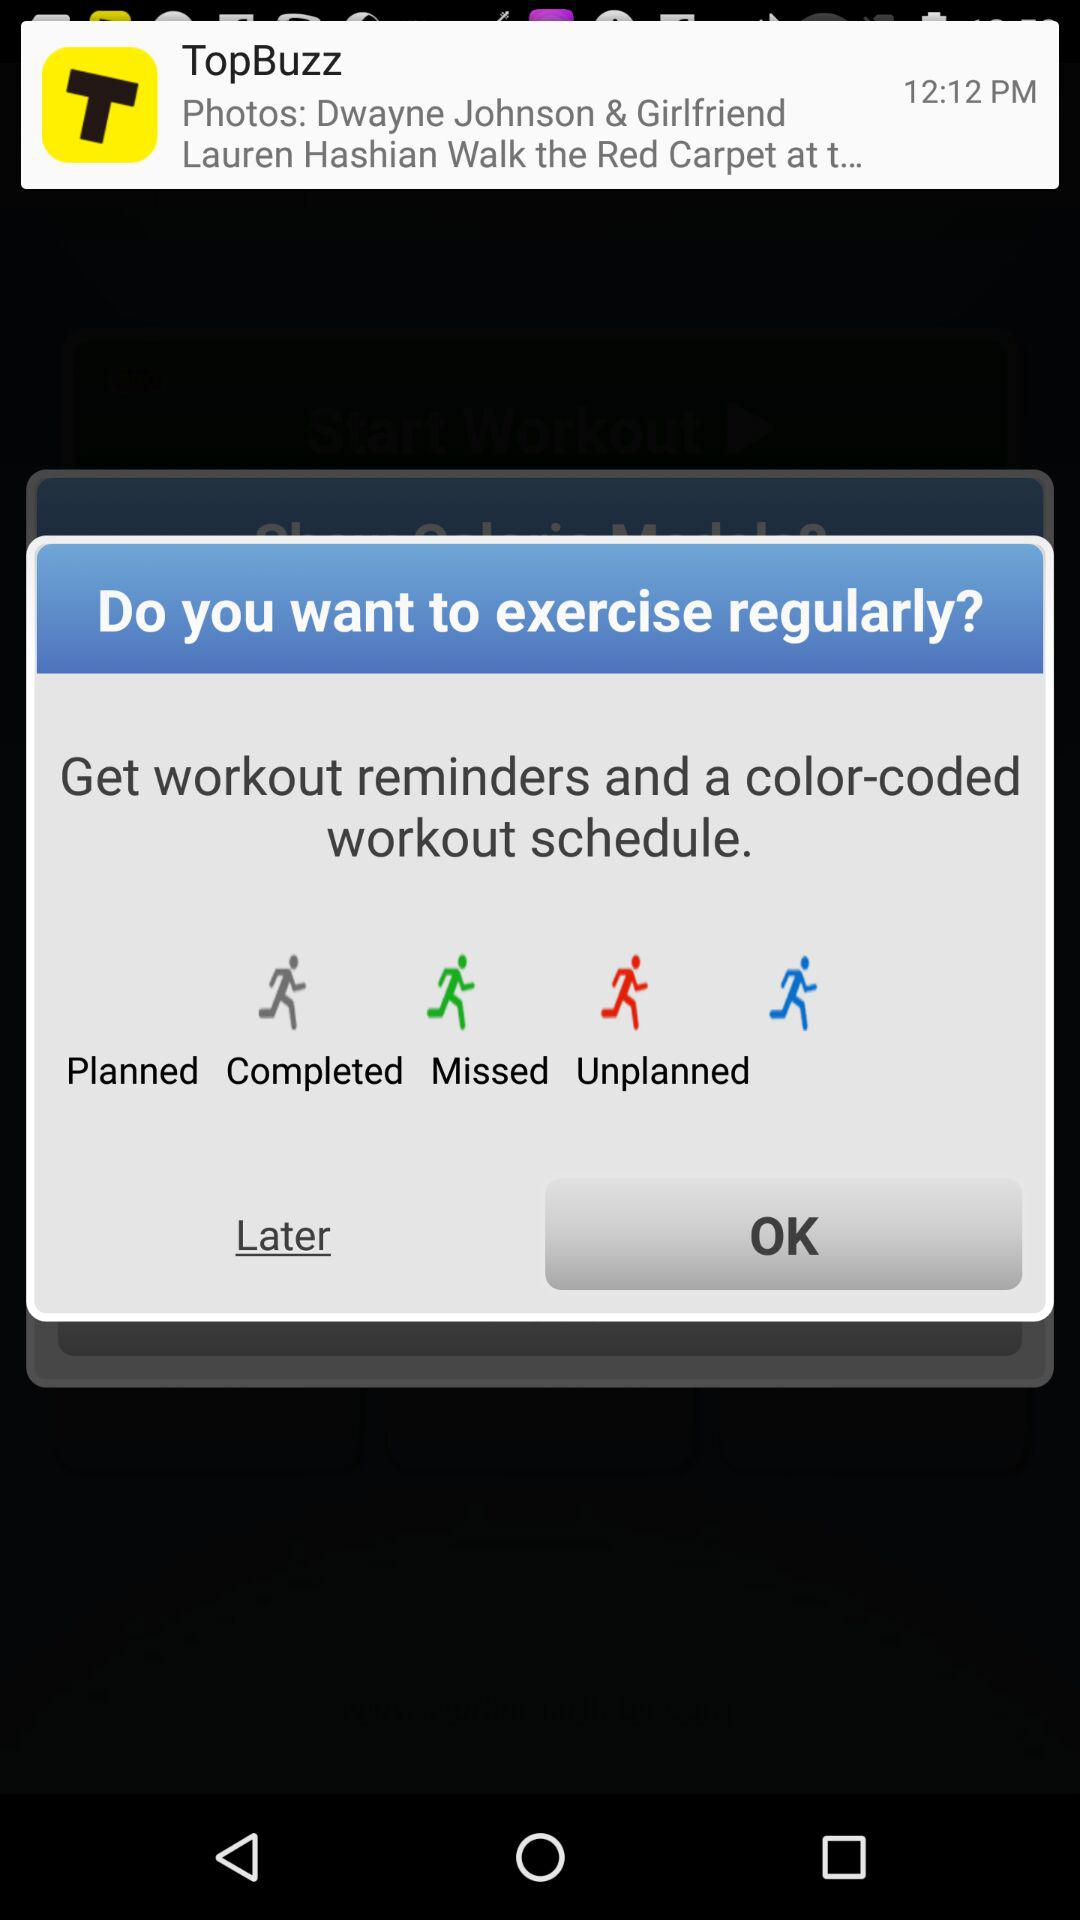What are the different color-coded workout statuses? The color-coded workout statuses are "Planned", "Completed", "Missed" and "Unplanned". 